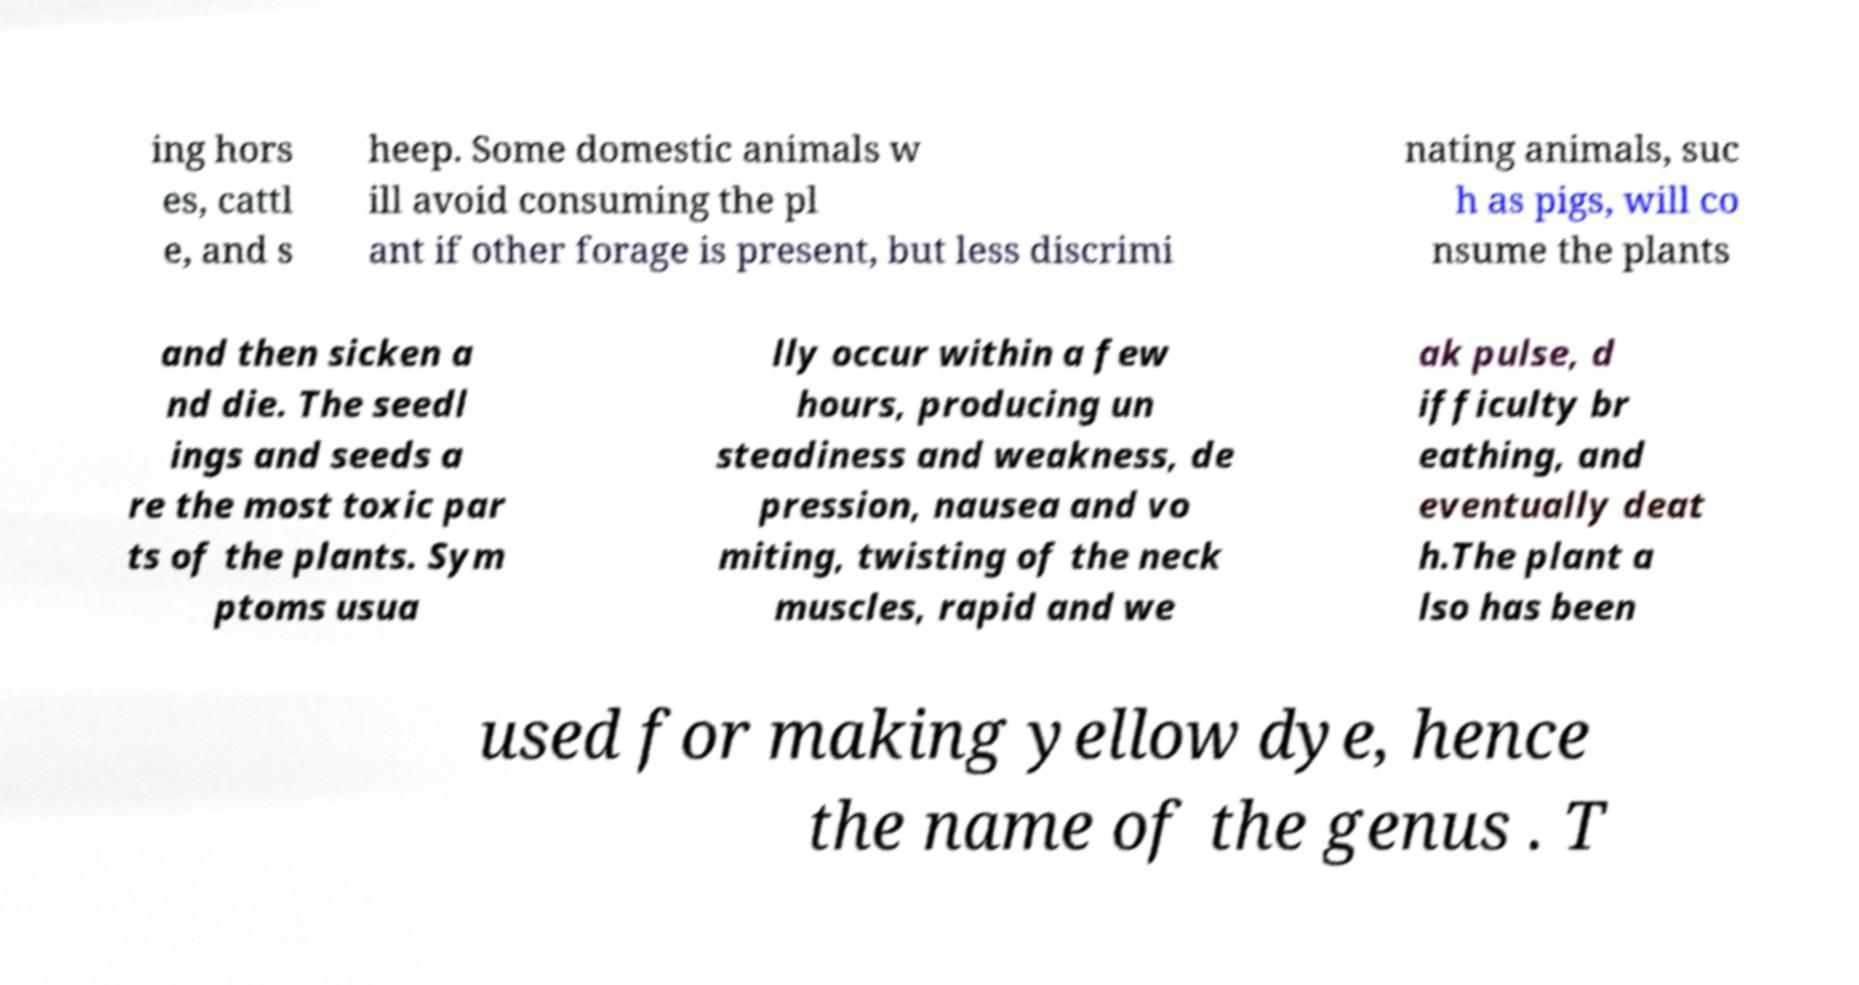Can you read and provide the text displayed in the image?This photo seems to have some interesting text. Can you extract and type it out for me? ing hors es, cattl e, and s heep. Some domestic animals w ill avoid consuming the pl ant if other forage is present, but less discrimi nating animals, suc h as pigs, will co nsume the plants and then sicken a nd die. The seedl ings and seeds a re the most toxic par ts of the plants. Sym ptoms usua lly occur within a few hours, producing un steadiness and weakness, de pression, nausea and vo miting, twisting of the neck muscles, rapid and we ak pulse, d ifficulty br eathing, and eventually deat h.The plant a lso has been used for making yellow dye, hence the name of the genus . T 